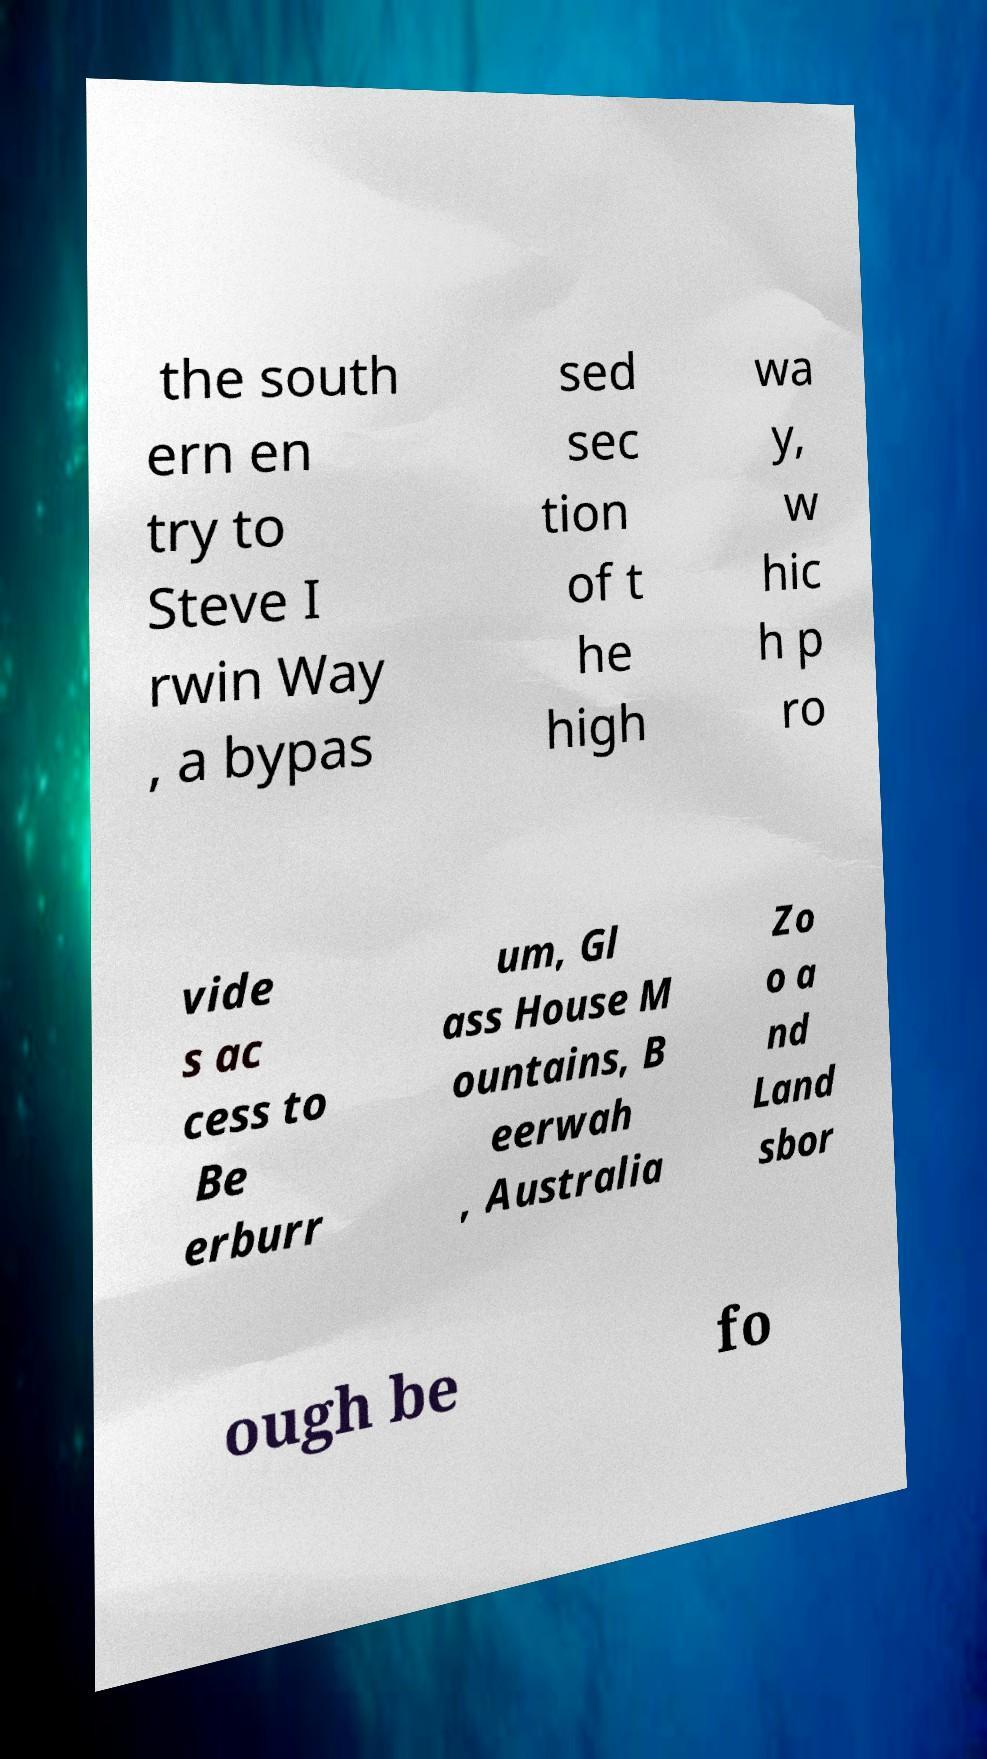Please identify and transcribe the text found in this image. the south ern en try to Steve I rwin Way , a bypas sed sec tion of t he high wa y, w hic h p ro vide s ac cess to Be erburr um, Gl ass House M ountains, B eerwah , Australia Zo o a nd Land sbor ough be fo 